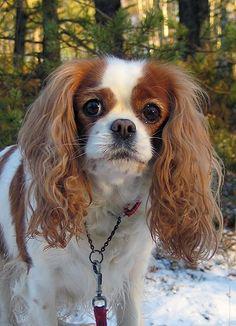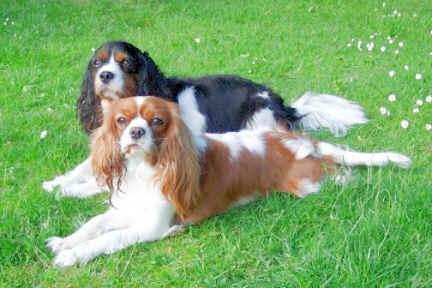The first image is the image on the left, the second image is the image on the right. For the images shown, is this caption "At least 1 brown and white dog is in the grass." true? Answer yes or no. Yes. The first image is the image on the left, the second image is the image on the right. Considering the images on both sides, is "There is at least one dog on top of grass." valid? Answer yes or no. Yes. 